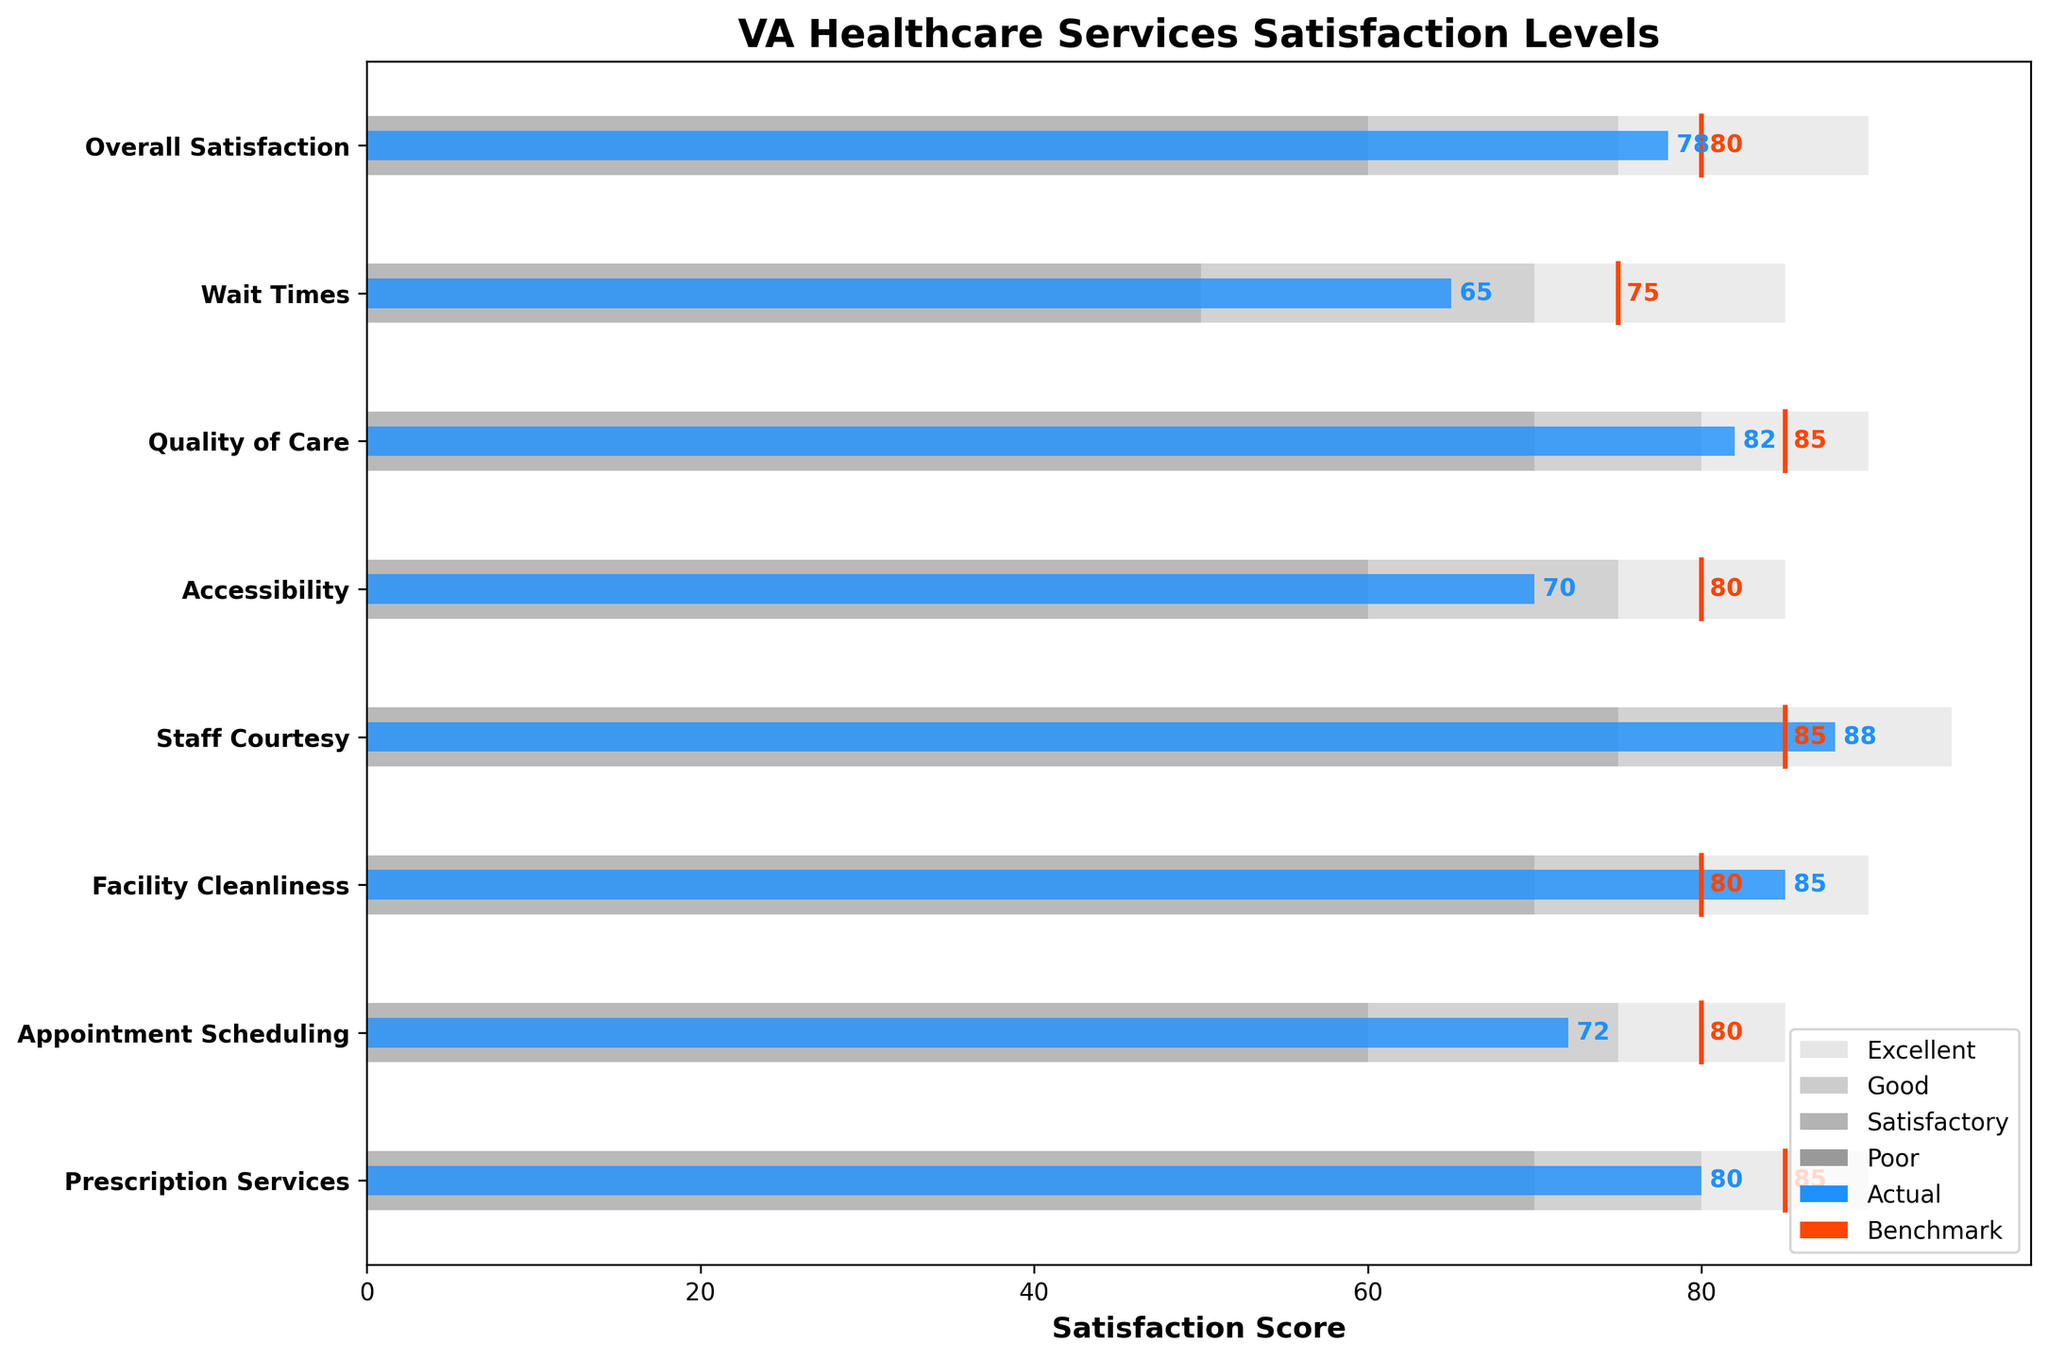What's the title of the chart? The title of the chart is displayed at the top of the figure in bold text. It provides an overview of what the chart is depicting. The title in this case is "VA Healthcare Services Satisfaction Levels".
Answer: VA Healthcare Services Satisfaction Levels What is the satisfaction score for Wait Times? The satisfaction scores are depicted by blue bars. To find the score for Wait Times, locate the "Wait Times" row and look at the length of the blue bar.
Answer: 65 Which category has the highest satisfaction score? To determine the highest satisfaction score, identify the longest blue bar among all categories. The longest blue bar will indicate the category with the highest score.
Answer: Staff Courtesy How many categories have satisfaction scores that meet or exceed the benchmarks? Compare the blue bars (actual scores) with the red vertical lines (benchmarks). Count how many blue bars are greater than or equal to their respective red lines.
Answer: 2 (Quality of Care, Staff Courtesy) What is the difference between the satisfaction score and the benchmark for Overall Satisfaction? Locate the "Overall Satisfaction" category and find the values for the blue bar (78) and the red line (80). Subtract the actual score from the benchmark to find the difference: 80 - 78 = 2.
Answer: 2 Which category has the largest gap between the actual score and the benchmark? For each category, subtract the actual score (blue bar) from the benchmark (red line) and compare the gaps. The category with the highest difference is the one we are looking for.
Answer: Wait Times What are the four levels of satisfaction indicated by different shades of gray? The four levels of satisfaction are indicated by the different background bars in shades of gray. From left to right, they are: Poor, Satisfactory, Good, Excellent.
Answer: Poor, Satisfactory, Good, Excellent Which category is closest to meeting its benchmark? To find the category closest to its benchmark, calculate the difference between the actual score (blue bar) and the benchmark (red line) for each category, and find the smallest difference.
Answer: Overall Satisfaction What is the benchmark score for Facility Cleanliness? Find the "Facility Cleanliness" category and identify the red vertical line, which represents the benchmark score.
Answer: 80 How many categories have an actual satisfaction score above 80? Count the number of blue bars (actual scores) that extend beyond the value of 80 on the x-axis.
Answer: 3 (Quality of Care, Staff Courtesy, Facility Cleanliness) 